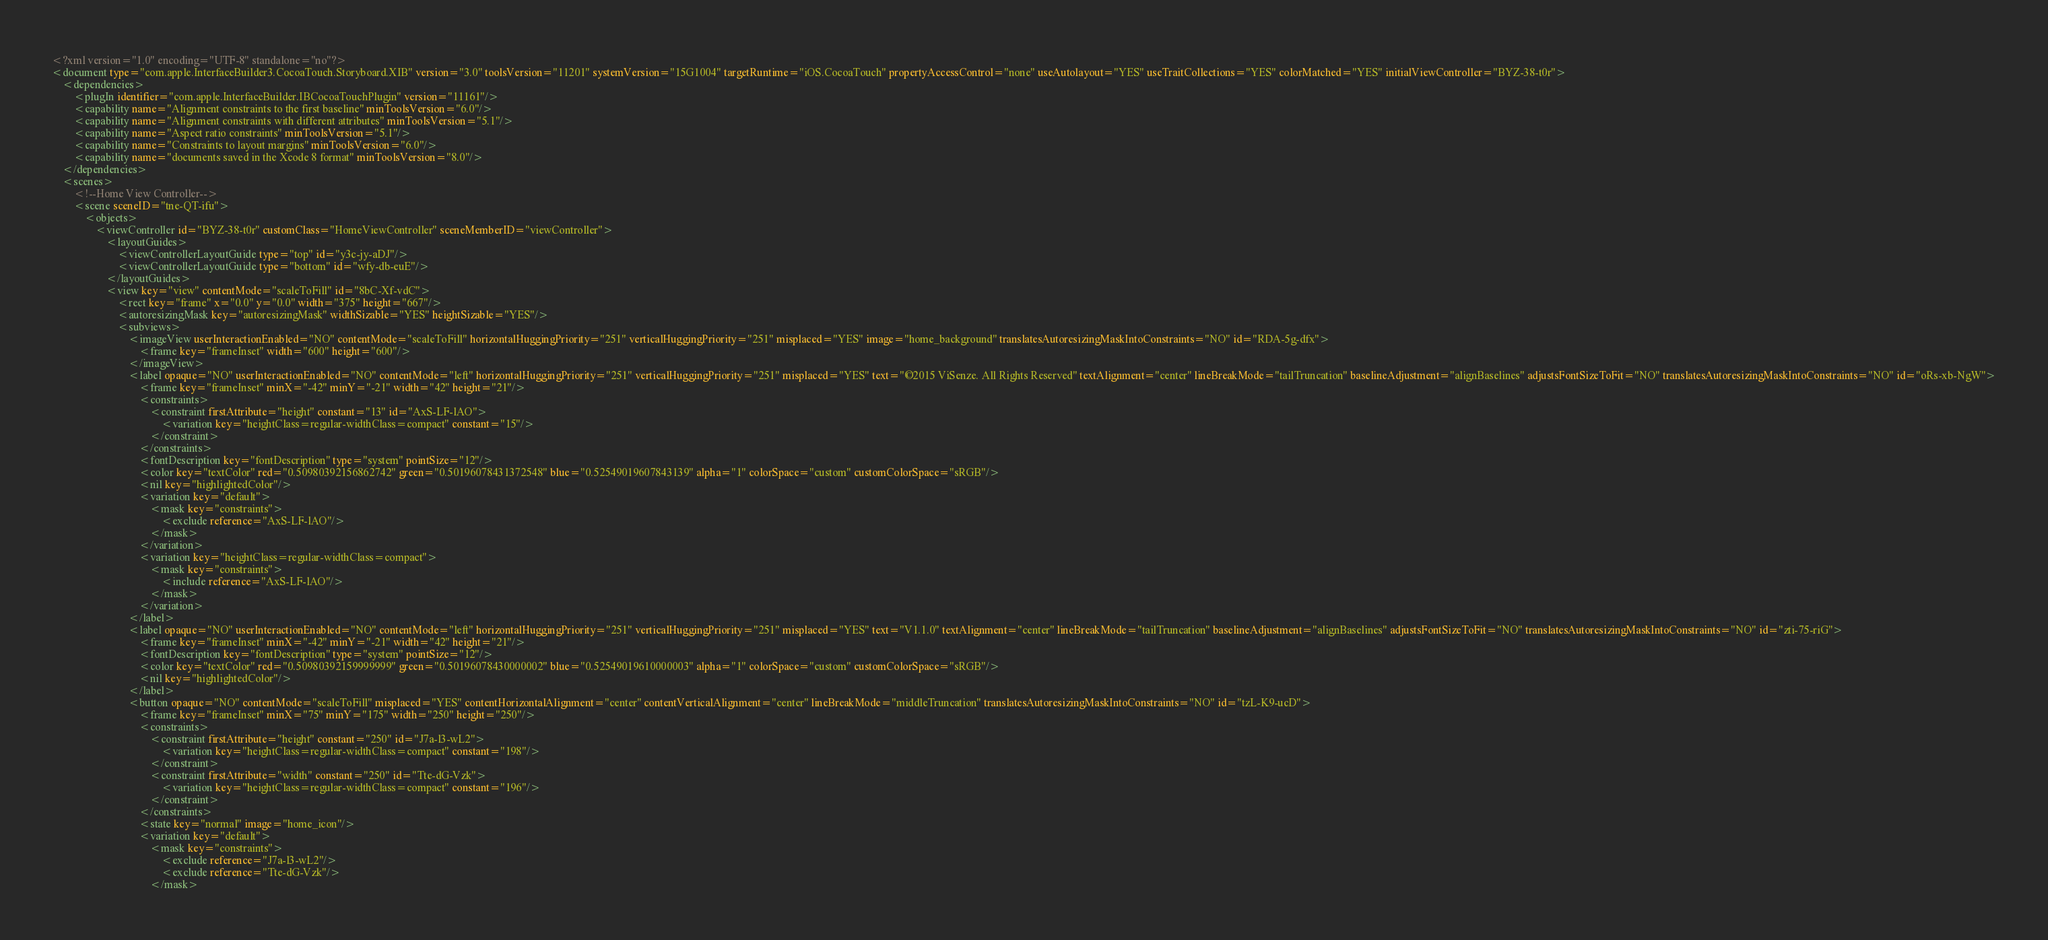<code> <loc_0><loc_0><loc_500><loc_500><_XML_><?xml version="1.0" encoding="UTF-8" standalone="no"?>
<document type="com.apple.InterfaceBuilder3.CocoaTouch.Storyboard.XIB" version="3.0" toolsVersion="11201" systemVersion="15G1004" targetRuntime="iOS.CocoaTouch" propertyAccessControl="none" useAutolayout="YES" useTraitCollections="YES" colorMatched="YES" initialViewController="BYZ-38-t0r">
    <dependencies>
        <plugIn identifier="com.apple.InterfaceBuilder.IBCocoaTouchPlugin" version="11161"/>
        <capability name="Alignment constraints to the first baseline" minToolsVersion="6.0"/>
        <capability name="Alignment constraints with different attributes" minToolsVersion="5.1"/>
        <capability name="Aspect ratio constraints" minToolsVersion="5.1"/>
        <capability name="Constraints to layout margins" minToolsVersion="6.0"/>
        <capability name="documents saved in the Xcode 8 format" minToolsVersion="8.0"/>
    </dependencies>
    <scenes>
        <!--Home View Controller-->
        <scene sceneID="tne-QT-ifu">
            <objects>
                <viewController id="BYZ-38-t0r" customClass="HomeViewController" sceneMemberID="viewController">
                    <layoutGuides>
                        <viewControllerLayoutGuide type="top" id="y3c-jy-aDJ"/>
                        <viewControllerLayoutGuide type="bottom" id="wfy-db-euE"/>
                    </layoutGuides>
                    <view key="view" contentMode="scaleToFill" id="8bC-Xf-vdC">
                        <rect key="frame" x="0.0" y="0.0" width="375" height="667"/>
                        <autoresizingMask key="autoresizingMask" widthSizable="YES" heightSizable="YES"/>
                        <subviews>
                            <imageView userInteractionEnabled="NO" contentMode="scaleToFill" horizontalHuggingPriority="251" verticalHuggingPriority="251" misplaced="YES" image="home_background" translatesAutoresizingMaskIntoConstraints="NO" id="RDA-5g-dfx">
                                <frame key="frameInset" width="600" height="600"/>
                            </imageView>
                            <label opaque="NO" userInteractionEnabled="NO" contentMode="left" horizontalHuggingPriority="251" verticalHuggingPriority="251" misplaced="YES" text="©2015 ViSenze. All Rights Reserved" textAlignment="center" lineBreakMode="tailTruncation" baselineAdjustment="alignBaselines" adjustsFontSizeToFit="NO" translatesAutoresizingMaskIntoConstraints="NO" id="oRs-xb-NgW">
                                <frame key="frameInset" minX="-42" minY="-21" width="42" height="21"/>
                                <constraints>
                                    <constraint firstAttribute="height" constant="13" id="AxS-LF-lAO">
                                        <variation key="heightClass=regular-widthClass=compact" constant="15"/>
                                    </constraint>
                                </constraints>
                                <fontDescription key="fontDescription" type="system" pointSize="12"/>
                                <color key="textColor" red="0.50980392156862742" green="0.50196078431372548" blue="0.52549019607843139" alpha="1" colorSpace="custom" customColorSpace="sRGB"/>
                                <nil key="highlightedColor"/>
                                <variation key="default">
                                    <mask key="constraints">
                                        <exclude reference="AxS-LF-lAO"/>
                                    </mask>
                                </variation>
                                <variation key="heightClass=regular-widthClass=compact">
                                    <mask key="constraints">
                                        <include reference="AxS-LF-lAO"/>
                                    </mask>
                                </variation>
                            </label>
                            <label opaque="NO" userInteractionEnabled="NO" contentMode="left" horizontalHuggingPriority="251" verticalHuggingPriority="251" misplaced="YES" text="V1.1.0" textAlignment="center" lineBreakMode="tailTruncation" baselineAdjustment="alignBaselines" adjustsFontSizeToFit="NO" translatesAutoresizingMaskIntoConstraints="NO" id="zti-75-riG">
                                <frame key="frameInset" minX="-42" minY="-21" width="42" height="21"/>
                                <fontDescription key="fontDescription" type="system" pointSize="12"/>
                                <color key="textColor" red="0.50980392159999999" green="0.50196078430000002" blue="0.52549019610000003" alpha="1" colorSpace="custom" customColorSpace="sRGB"/>
                                <nil key="highlightedColor"/>
                            </label>
                            <button opaque="NO" contentMode="scaleToFill" misplaced="YES" contentHorizontalAlignment="center" contentVerticalAlignment="center" lineBreakMode="middleTruncation" translatesAutoresizingMaskIntoConstraints="NO" id="tzL-K9-ucD">
                                <frame key="frameInset" minX="75" minY="175" width="250" height="250"/>
                                <constraints>
                                    <constraint firstAttribute="height" constant="250" id="J7a-l3-wL2">
                                        <variation key="heightClass=regular-widthClass=compact" constant="198"/>
                                    </constraint>
                                    <constraint firstAttribute="width" constant="250" id="Tte-dG-Vzk">
                                        <variation key="heightClass=regular-widthClass=compact" constant="196"/>
                                    </constraint>
                                </constraints>
                                <state key="normal" image="home_icon"/>
                                <variation key="default">
                                    <mask key="constraints">
                                        <exclude reference="J7a-l3-wL2"/>
                                        <exclude reference="Tte-dG-Vzk"/>
                                    </mask></code> 